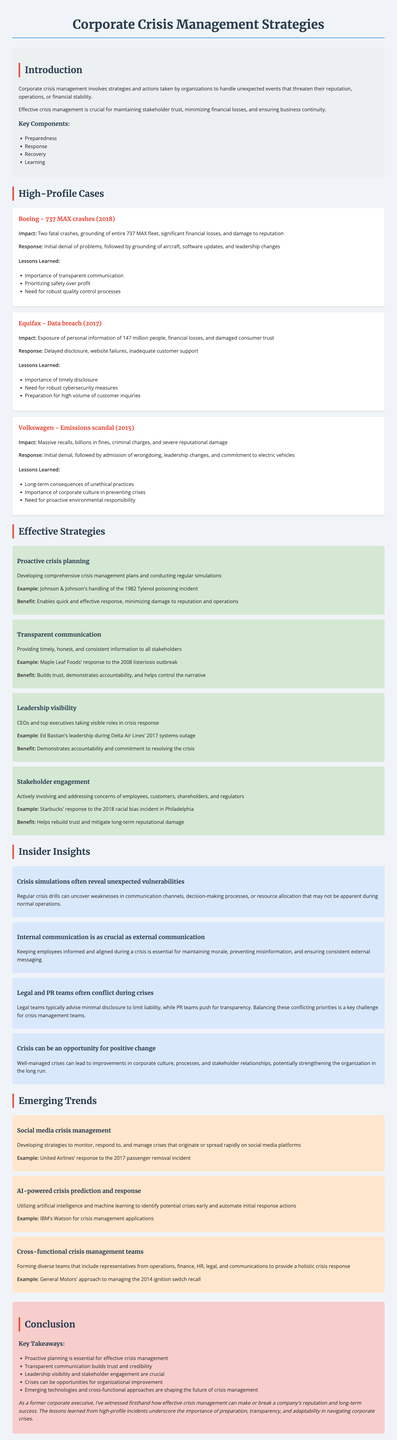What company faced a data breach in 2017? The document states that Equifax experienced a data breach in 2017, exposing personal information.
Answer: Equifax What was the impact of the Boeing 737 MAX crashes? The document mentions two fatal crashes, grounding of the fleet, and significant financial losses.
Answer: Two fatal crashes What is one lesson learned from the Volkswagen emissions scandal? The document lists the long-term consequences of unethical practices as a key lesson learned.
Answer: Long-term consequences of unethical practices What effective strategy is used for crisis planning? The document describes developing comprehensive crisis management plans and conducting regular simulations.
Answer: Proactive crisis planning Which company demonstrated leadership visibility during a crisis in 2017? The document highlights Ed Bastian's leadership during the Delta Air Lines systems outage.
Answer: Delta Air Lines What year did the Maple Leaf Foods listeriosis outbreak occur? The document indicates that the response took place in 2008.
Answer: 2008 What is a key takeaway from the document about crisis management? The document emphasizes proactive planning as essential for effective crisis management.
Answer: Proactive planning What emerging trend involves AI in crisis management? The document mentions using artificial intelligence and machine learning to identify potential crises early.
Answer: AI-powered crisis prediction and response What is a crucial factor for internal communication during crises? The document states that keeping employees informed is essential for maintaining morale.
Answer: Maintaining morale 